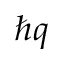Convert formula to latex. <formula><loc_0><loc_0><loc_500><loc_500>\hbar { q }</formula> 